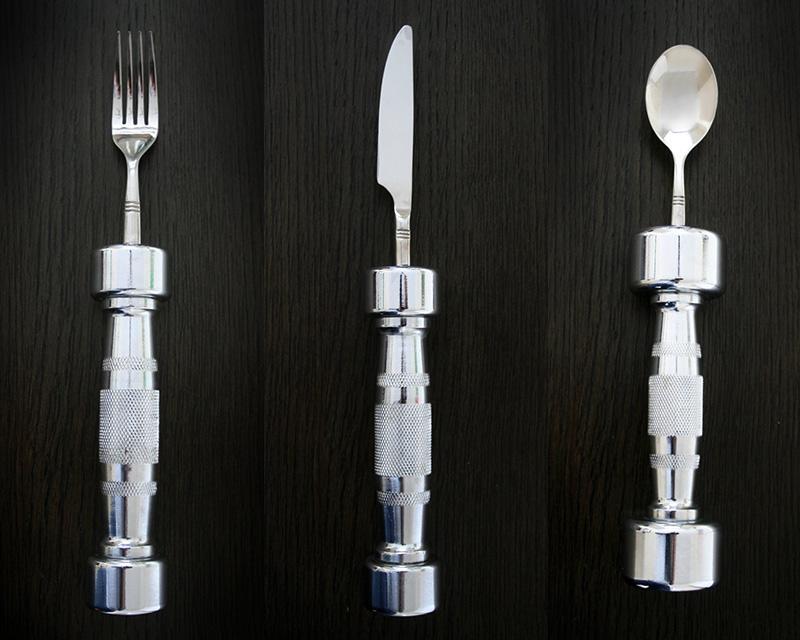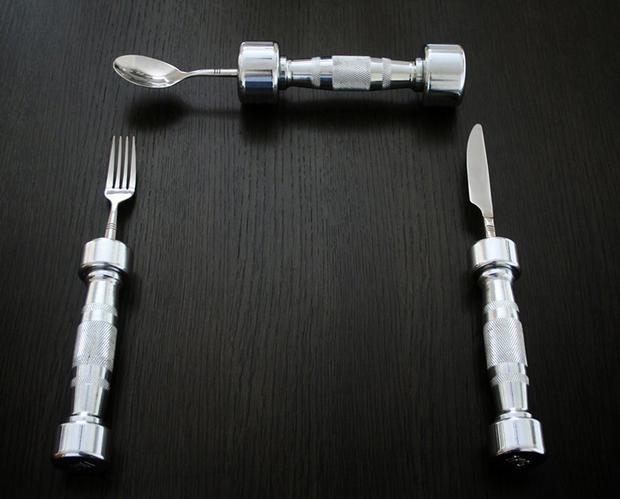The first image is the image on the left, the second image is the image on the right. Considering the images on both sides, is "There is a knife, fork, and spoon in the image on the right." valid? Answer yes or no. Yes. 